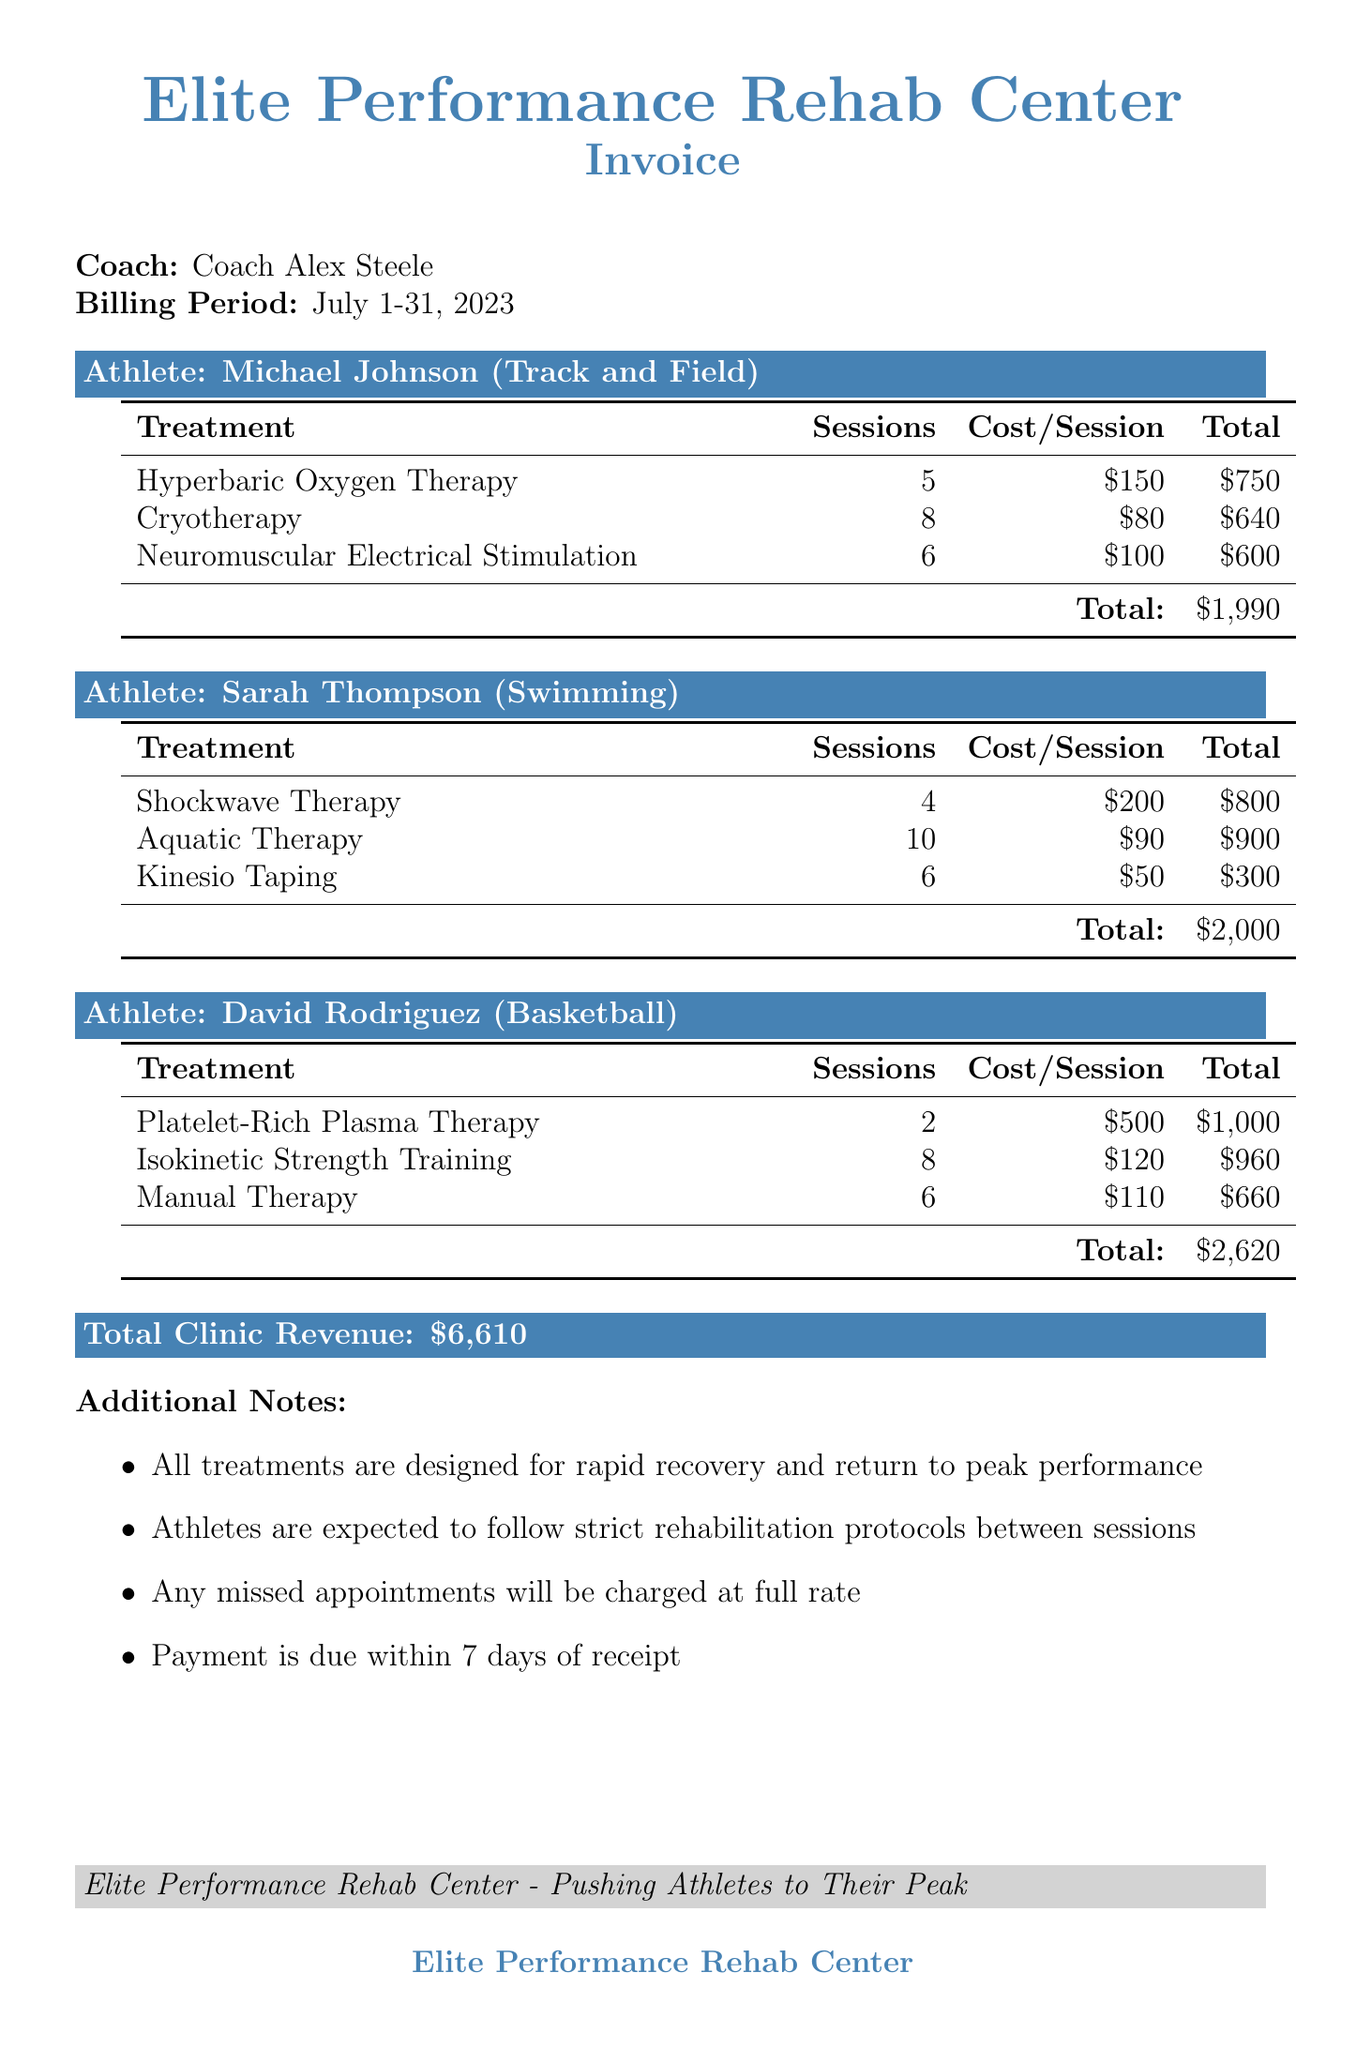What is the clinic name? The clinic name is specified at the top of the document.
Answer: Elite Performance Rehab Center What is the billing period? The billing period is mentioned immediately after the coach's name.
Answer: July 1-31, 2023 How many sessions of Cryotherapy did Michael Johnson have? This is found in the treatments section for Michael Johnson.
Answer: 8 What is the cost of one session of Shockwave Therapy? The cost per session is listed under Sarah Thompson's treatments.
Answer: $200 What is the total bill for David Rodriguez? The total bill is shown at the end of each athlete's treatment summary.
Answer: $2,620 Which treatment did Sarah Thompson have the most sessions of? This requires reviewing the sessions of each treatment under Sarah Thompson.
Answer: Aquatic Therapy How many total treatments did Michael Johnson receive? The total is determined by counting the number of treatment types listed for Michael.
Answer: 3 What is the purpose of all treatments stated in the additional notes? The additional notes clarify the overarching goal of the treatments.
Answer: Rapid recovery When is payment due after receipt? This is specified in the additional notes section of the document.
Answer: Within 7 days 